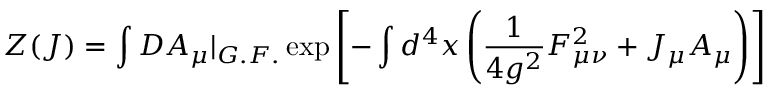<formula> <loc_0><loc_0><loc_500><loc_500>Z ( J ) = \int D A _ { \mu } | _ { G . F . } \exp \left [ - \int d ^ { 4 } x \left ( \frac { 1 } { 4 g ^ { 2 } } F _ { \mu \nu } ^ { 2 } + J _ { \mu } A _ { \mu } \right ) \right ]</formula> 